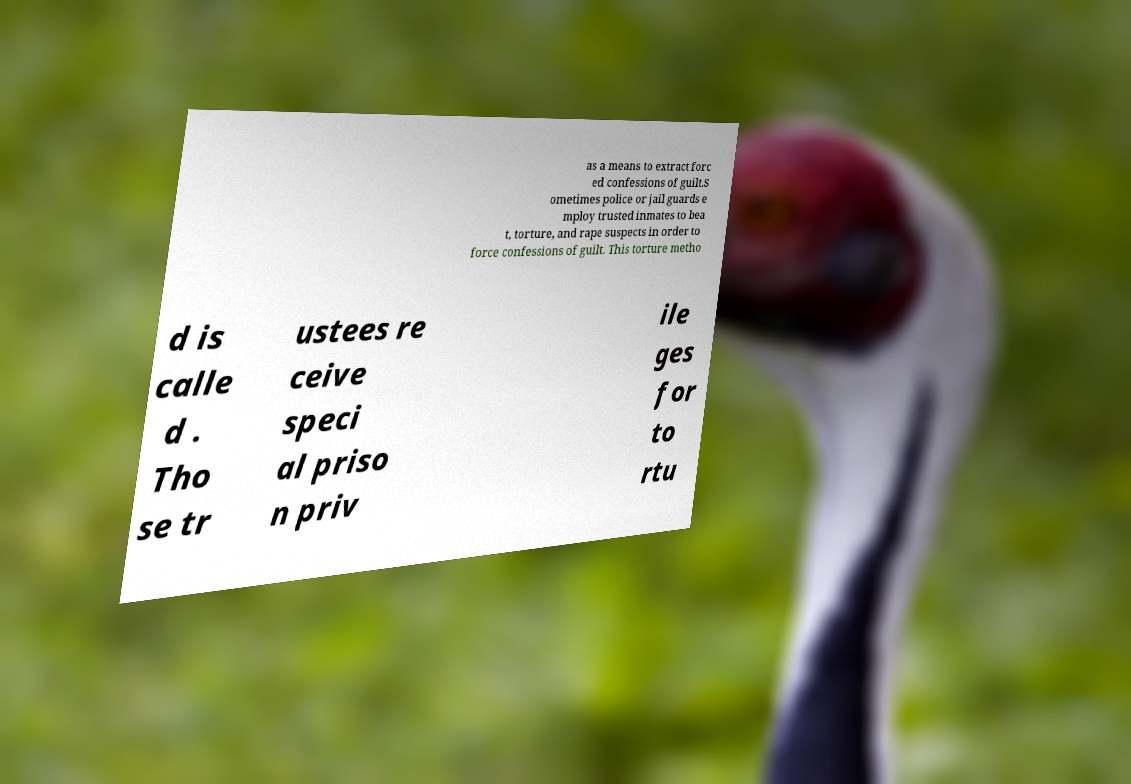I need the written content from this picture converted into text. Can you do that? as a means to extract forc ed confessions of guilt.S ometimes police or jail guards e mploy trusted inmates to bea t, torture, and rape suspects in order to force confessions of guilt. This torture metho d is calle d . Tho se tr ustees re ceive speci al priso n priv ile ges for to rtu 